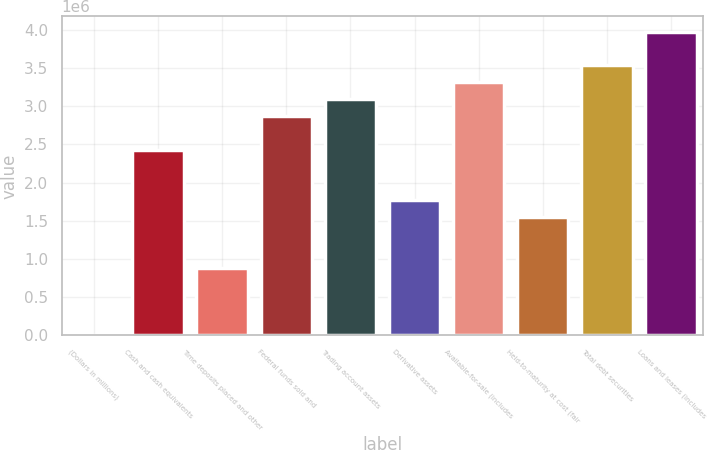Convert chart. <chart><loc_0><loc_0><loc_500><loc_500><bar_chart><fcel>(Dollars in millions)<fcel>Cash and cash equivalents<fcel>Time deposits placed and other<fcel>Federal funds sold and<fcel>Trading account assets<fcel>Derivative assets<fcel>Available-for-sale (includes<fcel>Held-to-maturity at cost (fair<fcel>Total debt securities<fcel>Loans and leases (includes<nl><fcel>2012<fcel>2.43077e+06<fcel>885197<fcel>2.87236e+06<fcel>3.09316e+06<fcel>1.76838e+06<fcel>3.31396e+06<fcel>1.54759e+06<fcel>3.53475e+06<fcel>3.97634e+06<nl></chart> 